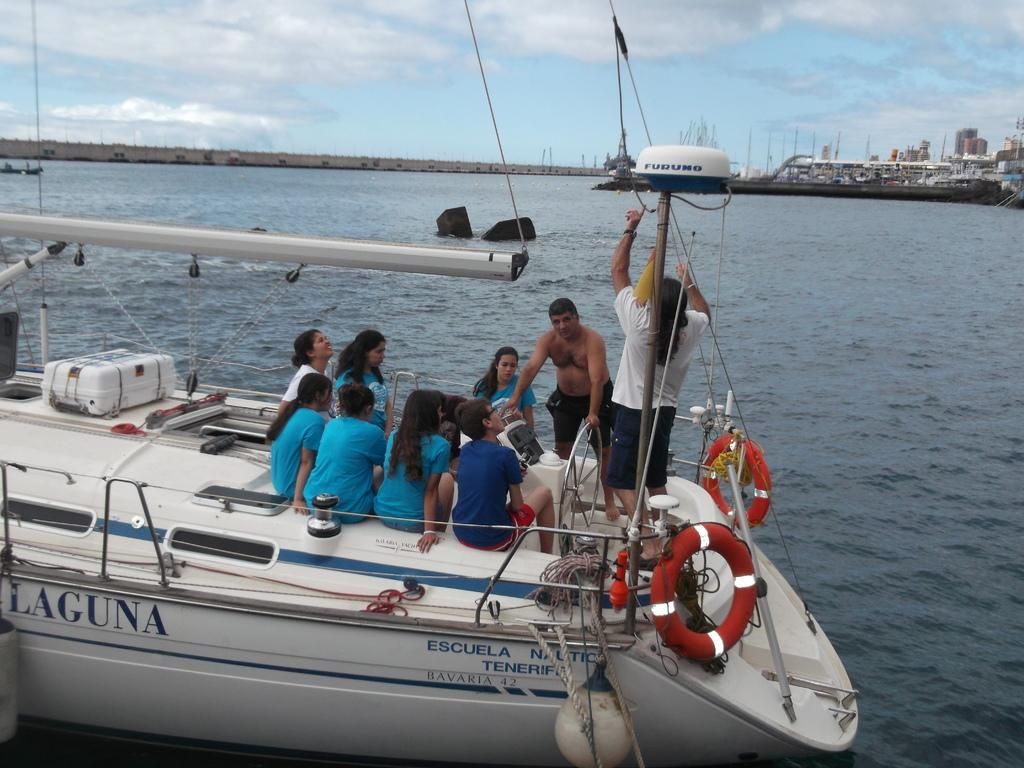Provide a one-sentence caption for the provided image. Lots of people on board the Laguna, ready to head out. 